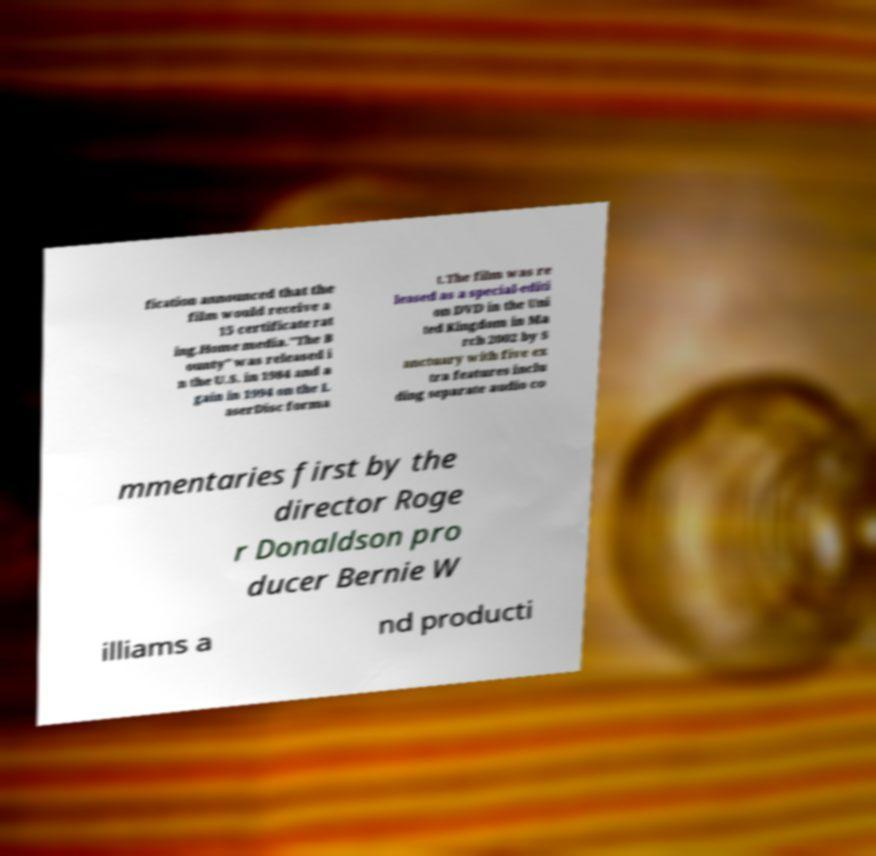Can you accurately transcribe the text from the provided image for me? fication announced that the film would receive a 15 certificate rat ing.Home media."The B ounty" was released i n the U.S. in 1984 and a gain in 1994 on the L aserDisc forma t.The film was re leased as a special-editi on DVD in the Uni ted Kingdom in Ma rch 2002 by S anctuary with five ex tra features inclu ding separate audio co mmentaries first by the director Roge r Donaldson pro ducer Bernie W illiams a nd producti 